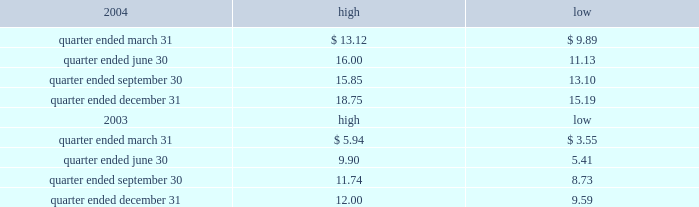Part ii item 5 .
Market for registrant 2019s common equity , related stockholder matters and issuer purchases of equity securities the table presents reported quarterly high and low per share sale prices of our class a common stock on the new york stock exchange ( nyse ) for the years 2004 and 2003. .
On march 18 , 2005 , the closing price of our class a common stock was $ 18.79 per share as reported on the as of march 18 , 2005 , we had 230604932 outstanding shares of class a common stock and 743 registered holders .
In february 2004 , all outstanding shares of our class b common stock were converted into shares of our class a common stock on a one-for-one basis pursuant to the occurrence of the 201cdodge conversion event 201d as defined in our charter .
Our charter prohibits the future issuance of shares of class b common stock .
Also in february 2004 , all outstanding shares of class c common stock were converted into shares of class a common stock on a one-for-one basis .
Our charter permits the issuance of shares of class c common stock in the future .
The information under 201csecurities authorized for issuance under equity compensation plans 201d from the definitive proxy statement is hereby incorporated by reference into item 12 of this annual report .
Dividends we have never paid a dividend on any class of common stock .
We anticipate that we may retain future earnings , if any , to fund the development and growth of our business .
The indentures governing our 93 20448% ( 20448 % ) senior notes due 2009 , our 7.50% ( 7.50 % ) senior notes due 2012 , and our 7.125% ( 7.125 % ) senior notes due 2012 prohibit us from paying dividends to our stockholders unless we satisfy certain financial covenants .
Our borrower subsidiaries are generally prohibited under the terms of the credit facility , subject to certain exceptions , from making to us any direct or indirect distribution , dividend or other payment on account of their limited liability company interests , partnership interests , capital stock or other equity interests , except that , if no default exists or would be created thereby under the credit facility , our borrower subsidiaries may pay cash dividends or make other distributions to us in accordance with the credit facility within certain specified amounts and , in addition , may pay cash dividends or make other distributions to us in respect of our outstanding indebtedness and permitted future indebtedness .
The indentures governing the 12.25% ( 12.25 % ) senior subordinated discount notes due 2008 and the 7.25% ( 7.25 % ) senior subordinated notes due 2011 of american towers , inc .
( ati ) , our principal operating subsidiary , prohibit ati and certain of our other subsidiaries that have guaranteed those notes ( sister guarantors ) from paying dividends and making other payments or distributions to us unless certain .
What is the growth rate in the price of shares from the lowest value during the quarter ended december 31 , 2004 and the closing price on march 18 , 2005? 
Computations: ((18.79 - 15.19) / 15.19)
Answer: 0.237. 